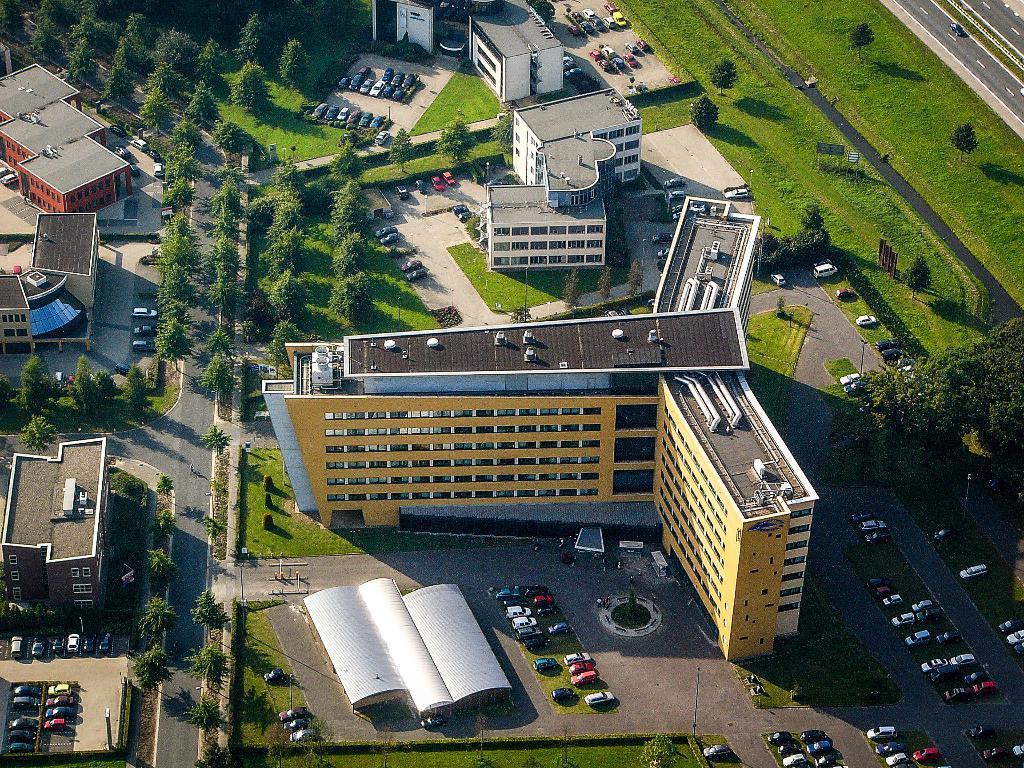Please provide a concise description of this image. This image is taken from the top, where we can see trees, buildings, road, new vehicles parked, grass, poles and a car moving on the road. 